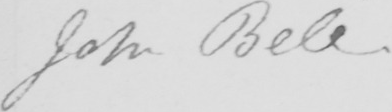What is written in this line of handwriting? John Bell . 